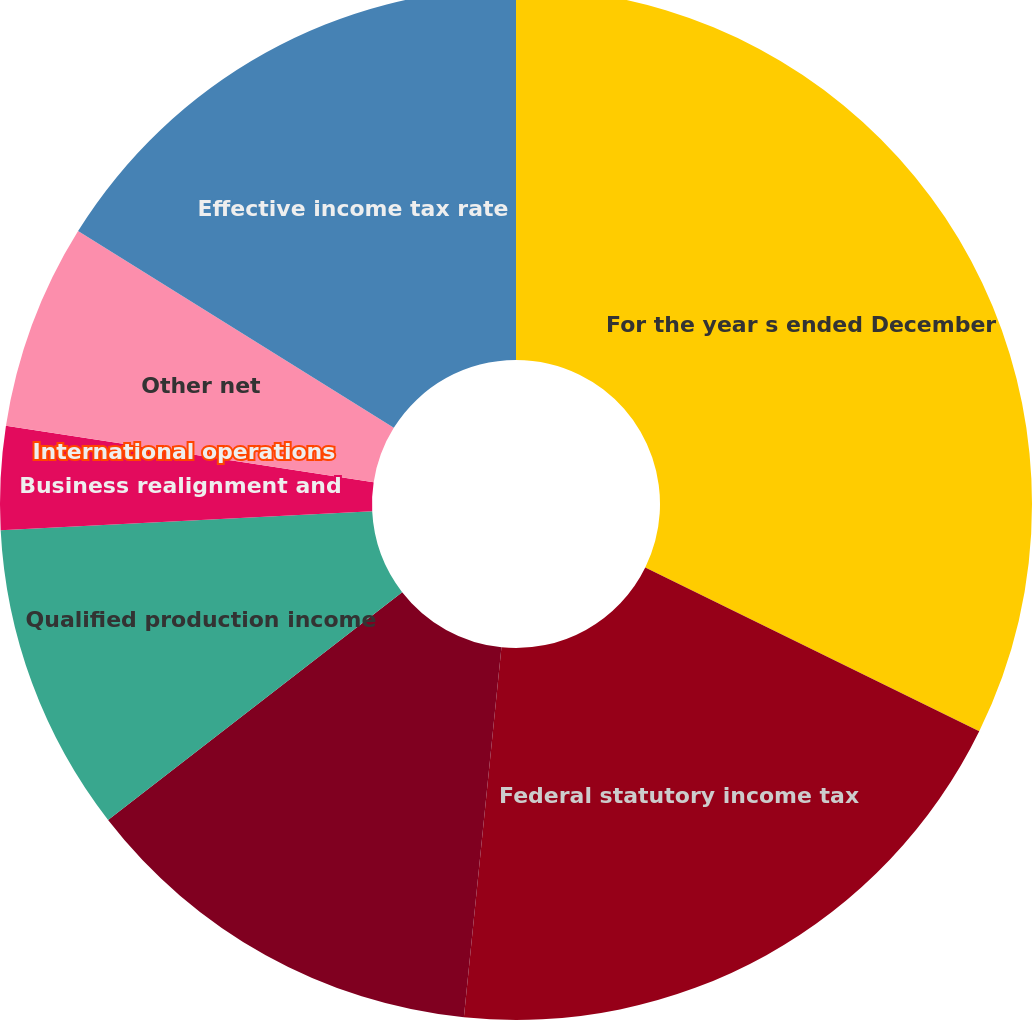Convert chart to OTSL. <chart><loc_0><loc_0><loc_500><loc_500><pie_chart><fcel>For the year s ended December<fcel>Federal statutory income tax<fcel>State income taxes net of<fcel>Qualified production income<fcel>Business realignment and<fcel>International operations<fcel>Other net<fcel>Effective income tax rate<nl><fcel>32.26%<fcel>19.35%<fcel>12.9%<fcel>9.68%<fcel>3.23%<fcel>0.0%<fcel>6.45%<fcel>16.13%<nl></chart> 